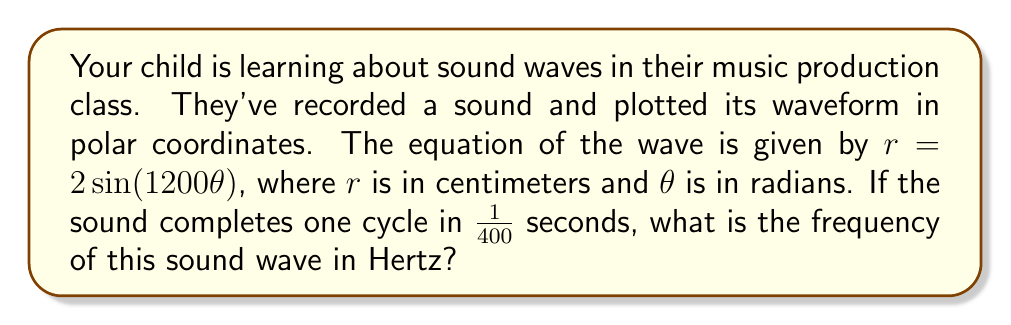What is the answer to this math problem? Let's approach this step-by-step:

1) In polar form, a complete cycle of the wave occurs when $\theta$ increases by $2\pi$ radians.

2) From the equation $r = 2 \sin(1200\theta)$, we can see that one complete cycle occurs when $1200\theta = 2\pi$, or when $\theta = \frac{2\pi}{1200} = \frac{\pi}{600}$ radians.

3) We're told that this cycle takes $\frac{1}{400}$ seconds to complete.

4) The frequency is the number of cycles per second. To find this, we need to determine how many of these $\frac{1}{400}$-second intervals fit into one second.

5) We can calculate this by dividing 1 second by $\frac{1}{400}$ seconds:

   $$f = \frac{1}{\frac{1}{400}} = 400 \text{ Hz}$$

6) Therefore, the frequency of the sound wave is 400 Hz.

This frequency falls within the audible range for humans (typically 20 Hz to 20,000 Hz), which is reassuring for a parent concerned about their child's music pursuits.
Answer: 400 Hz 